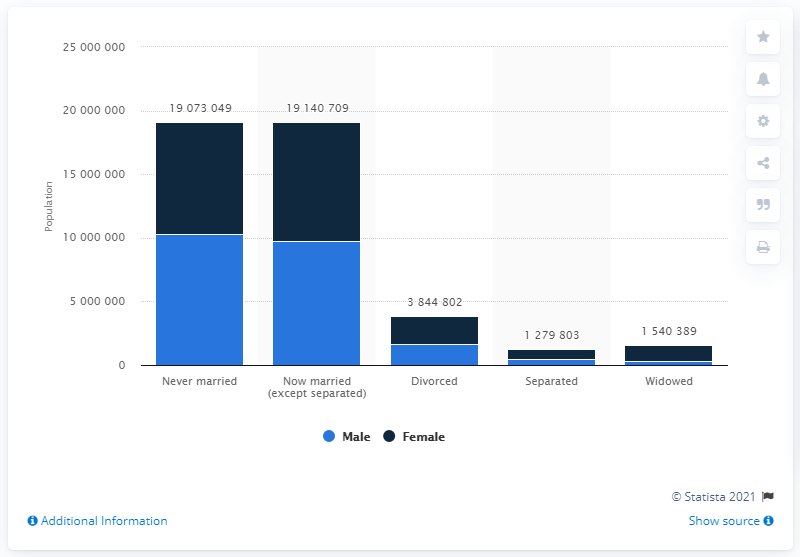Indicate a few pertinent items in this graphic. In 2019, a total of 10,293,331 Hispanic males were married in the United States. 